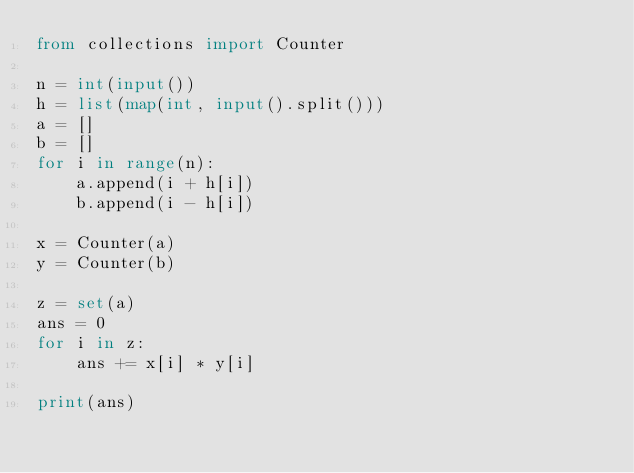<code> <loc_0><loc_0><loc_500><loc_500><_Python_>from collections import Counter

n = int(input())
h = list(map(int, input().split()))
a = []
b = []
for i in range(n):
    a.append(i + h[i])
    b.append(i - h[i])

x = Counter(a)
y = Counter(b)

z = set(a)
ans = 0
for i in z:
    ans += x[i] * y[i]

print(ans)</code> 